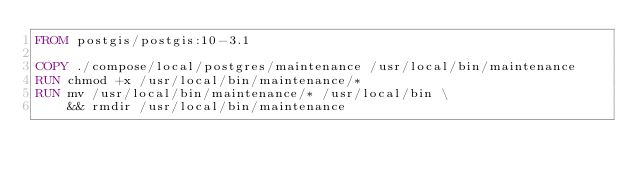<code> <loc_0><loc_0><loc_500><loc_500><_Dockerfile_>FROM postgis/postgis:10-3.1

COPY ./compose/local/postgres/maintenance /usr/local/bin/maintenance
RUN chmod +x /usr/local/bin/maintenance/*
RUN mv /usr/local/bin/maintenance/* /usr/local/bin \
    && rmdir /usr/local/bin/maintenance
</code> 